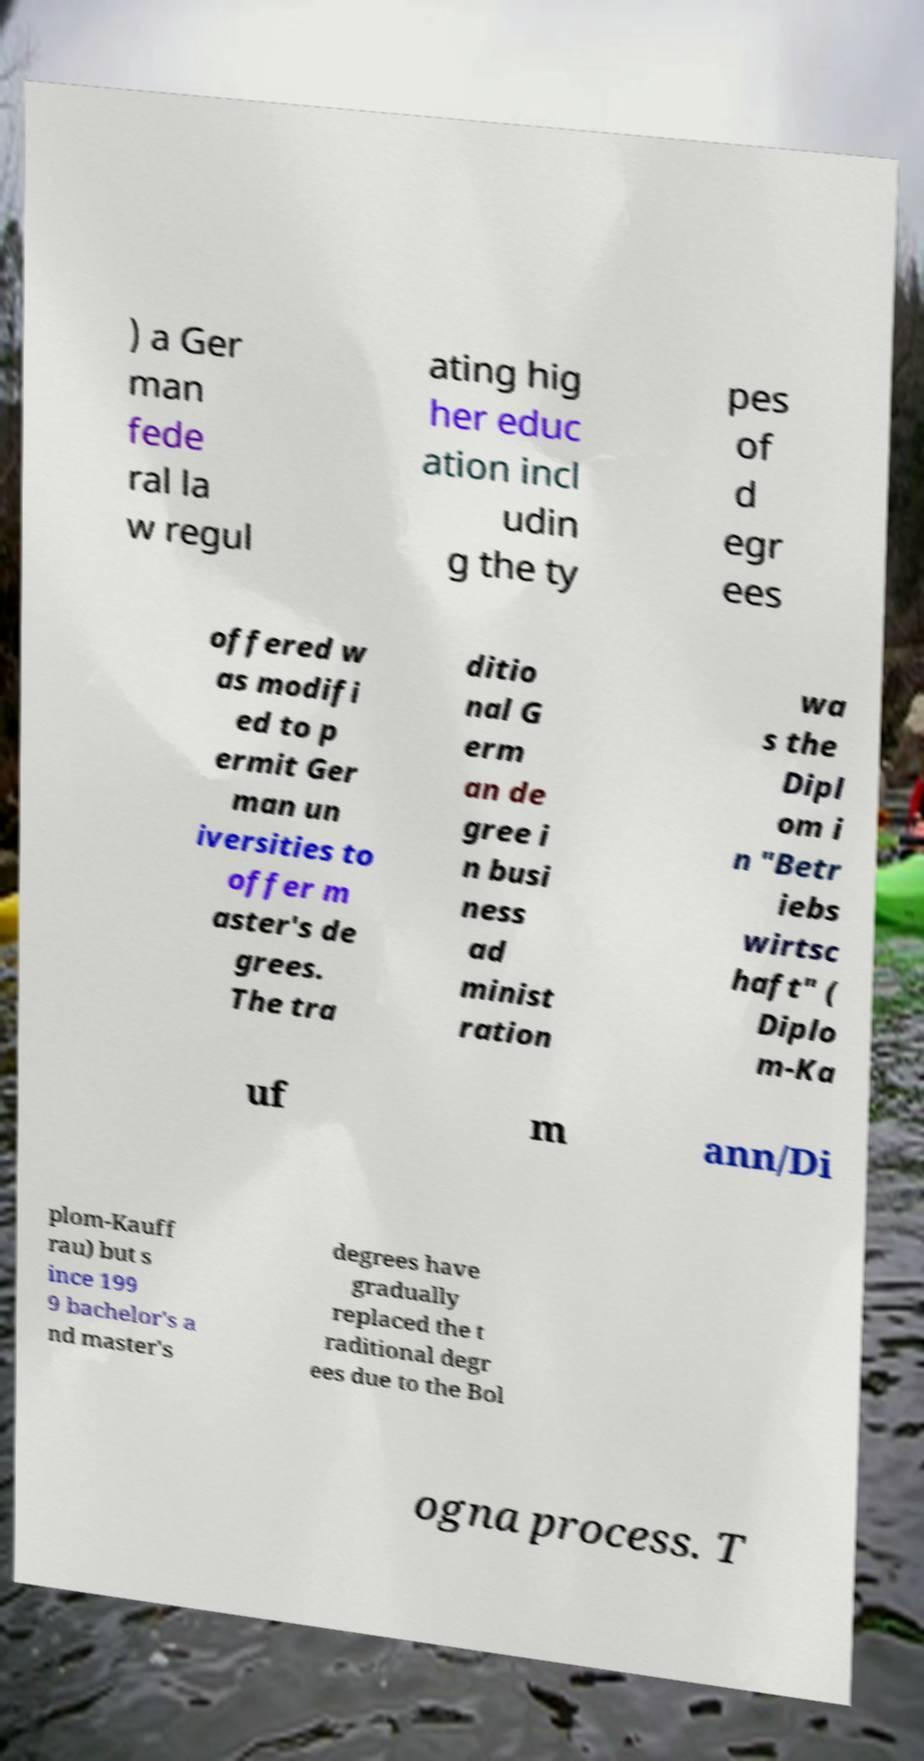Could you assist in decoding the text presented in this image and type it out clearly? ) a Ger man fede ral la w regul ating hig her educ ation incl udin g the ty pes of d egr ees offered w as modifi ed to p ermit Ger man un iversities to offer m aster's de grees. The tra ditio nal G erm an de gree i n busi ness ad minist ration wa s the Dipl om i n "Betr iebs wirtsc haft" ( Diplo m-Ka uf m ann/Di plom-Kauff rau) but s ince 199 9 bachelor's a nd master's degrees have gradually replaced the t raditional degr ees due to the Bol ogna process. T 